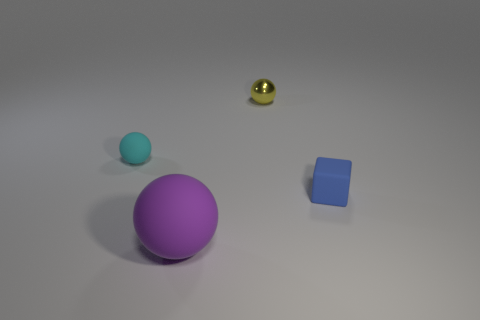Subtract all tiny balls. How many balls are left? 1 Add 3 tiny metal objects. How many objects exist? 7 Subtract all cubes. How many objects are left? 3 Subtract all small blue rubber blocks. Subtract all green balls. How many objects are left? 3 Add 2 purple rubber things. How many purple rubber things are left? 3 Add 4 big purple matte things. How many big purple matte things exist? 5 Subtract 0 brown cylinders. How many objects are left? 4 